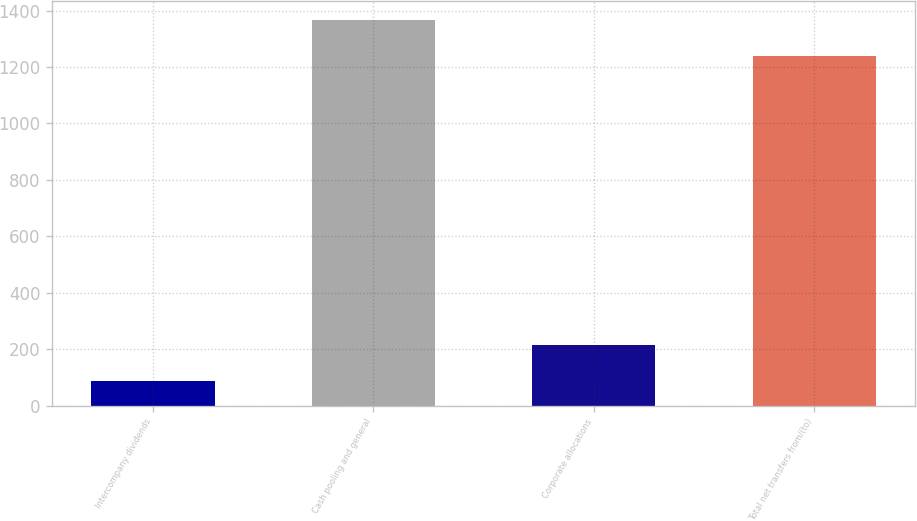<chart> <loc_0><loc_0><loc_500><loc_500><bar_chart><fcel>Intercompany dividends<fcel>Cash pooling and general<fcel>Corporate allocations<fcel>Total net transfers from/(to)<nl><fcel>87<fcel>1366.8<fcel>213.8<fcel>1240<nl></chart> 